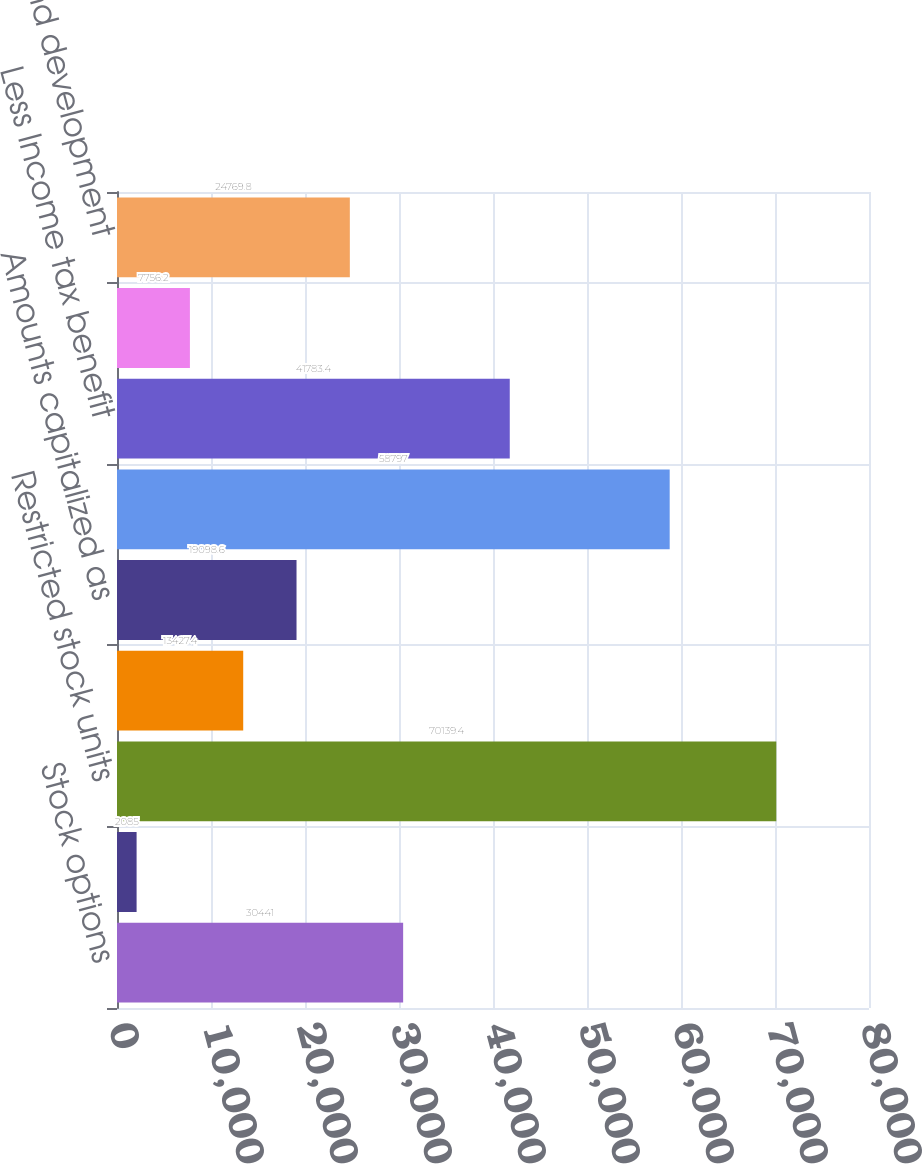Convert chart to OTSL. <chart><loc_0><loc_0><loc_500><loc_500><bar_chart><fcel>Stock options<fcel>Deferred stock units<fcel>Restricted stock units<fcel>Shares issued under the 1999<fcel>Amounts capitalized as<fcel>Total stock-based compensation<fcel>Less Income tax benefit<fcel>Cost of revenues<fcel>Research and development<nl><fcel>30441<fcel>2085<fcel>70139.4<fcel>13427.4<fcel>19098.6<fcel>58797<fcel>41783.4<fcel>7756.2<fcel>24769.8<nl></chart> 